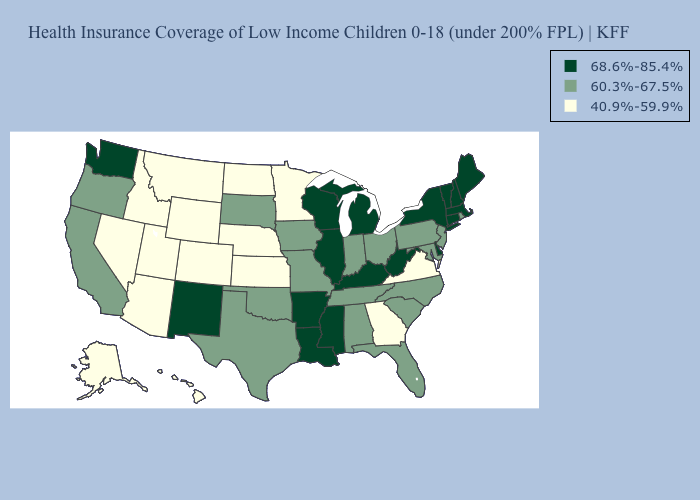What is the value of Wisconsin?
Write a very short answer. 68.6%-85.4%. Does Maine have the same value as New York?
Write a very short answer. Yes. Does North Dakota have the lowest value in the USA?
Short answer required. Yes. What is the highest value in the MidWest ?
Give a very brief answer. 68.6%-85.4%. What is the value of Delaware?
Keep it brief. 68.6%-85.4%. Name the states that have a value in the range 68.6%-85.4%?
Concise answer only. Arkansas, Connecticut, Delaware, Illinois, Kentucky, Louisiana, Maine, Massachusetts, Michigan, Mississippi, New Hampshire, New Mexico, New York, Vermont, Washington, West Virginia, Wisconsin. Among the states that border New Mexico , which have the highest value?
Give a very brief answer. Oklahoma, Texas. Name the states that have a value in the range 40.9%-59.9%?
Be succinct. Alaska, Arizona, Colorado, Georgia, Hawaii, Idaho, Kansas, Minnesota, Montana, Nebraska, Nevada, North Dakota, Utah, Virginia, Wyoming. Name the states that have a value in the range 60.3%-67.5%?
Concise answer only. Alabama, California, Florida, Indiana, Iowa, Maryland, Missouri, New Jersey, North Carolina, Ohio, Oklahoma, Oregon, Pennsylvania, Rhode Island, South Carolina, South Dakota, Tennessee, Texas. Which states have the highest value in the USA?
Answer briefly. Arkansas, Connecticut, Delaware, Illinois, Kentucky, Louisiana, Maine, Massachusetts, Michigan, Mississippi, New Hampshire, New Mexico, New York, Vermont, Washington, West Virginia, Wisconsin. What is the value of Oklahoma?
Keep it brief. 60.3%-67.5%. What is the value of Iowa?
Short answer required. 60.3%-67.5%. Name the states that have a value in the range 68.6%-85.4%?
Give a very brief answer. Arkansas, Connecticut, Delaware, Illinois, Kentucky, Louisiana, Maine, Massachusetts, Michigan, Mississippi, New Hampshire, New Mexico, New York, Vermont, Washington, West Virginia, Wisconsin. Name the states that have a value in the range 60.3%-67.5%?
Concise answer only. Alabama, California, Florida, Indiana, Iowa, Maryland, Missouri, New Jersey, North Carolina, Ohio, Oklahoma, Oregon, Pennsylvania, Rhode Island, South Carolina, South Dakota, Tennessee, Texas. What is the lowest value in the Northeast?
Concise answer only. 60.3%-67.5%. 